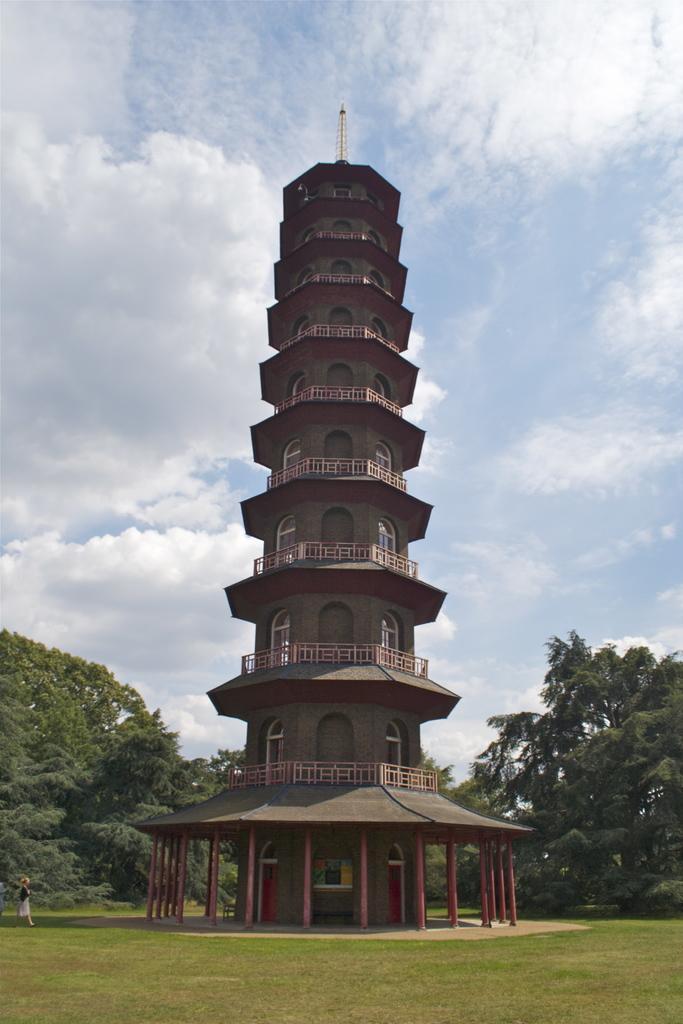In one or two sentences, can you explain what this image depicts? In this picture there is a person and we can see grass, pillars and architecture, top of the architecture we can see pole. In the background of the image we can see trees and sky with clouds. 